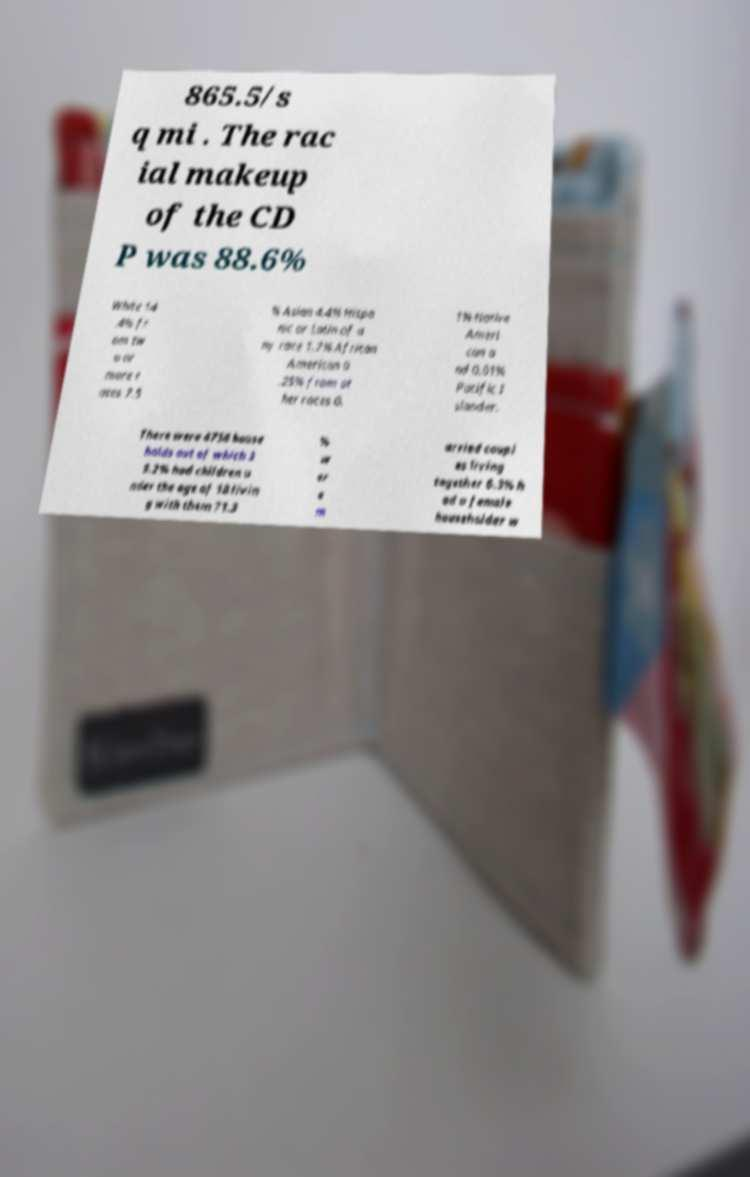There's text embedded in this image that I need extracted. Can you transcribe it verbatim? 865.5/s q mi . The rac ial makeup of the CD P was 88.6% White 14 .4% fr om tw o or more r aces 7.5 % Asian 4.4% Hispa nic or Latin of a ny race 1.7% African American 0 .25% from ot her races 0. 1% Native Ameri can a nd 0.01% Pacific I slander. There were 4758 house holds out of which 3 9.2% had children u nder the age of 18 livin g with them 71.3 % w er e m arried coupl es living together 6.3% h ad a female householder w 